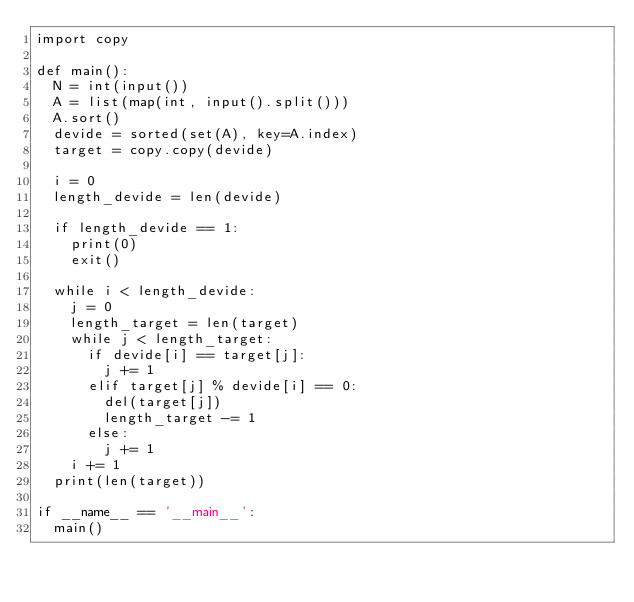<code> <loc_0><loc_0><loc_500><loc_500><_Python_>import copy

def main():
  N = int(input())
  A = list(map(int, input().split()))
  A.sort()
  devide = sorted(set(A), key=A.index)
  target = copy.copy(devide)
  
  i = 0
  length_devide = len(devide)
  
  if length_devide == 1:
    print(0)
    exit()
    
  while i < length_devide:
    j = 0
    length_target = len(target)
    while j < length_target:
      if devide[i] == target[j]:
        j += 1
      elif target[j] % devide[i] == 0:
        del(target[j])
        length_target -= 1
      else:
        j += 1
    i += 1
  print(len(target))
    
if __name__ == '__main__':
  main()</code> 